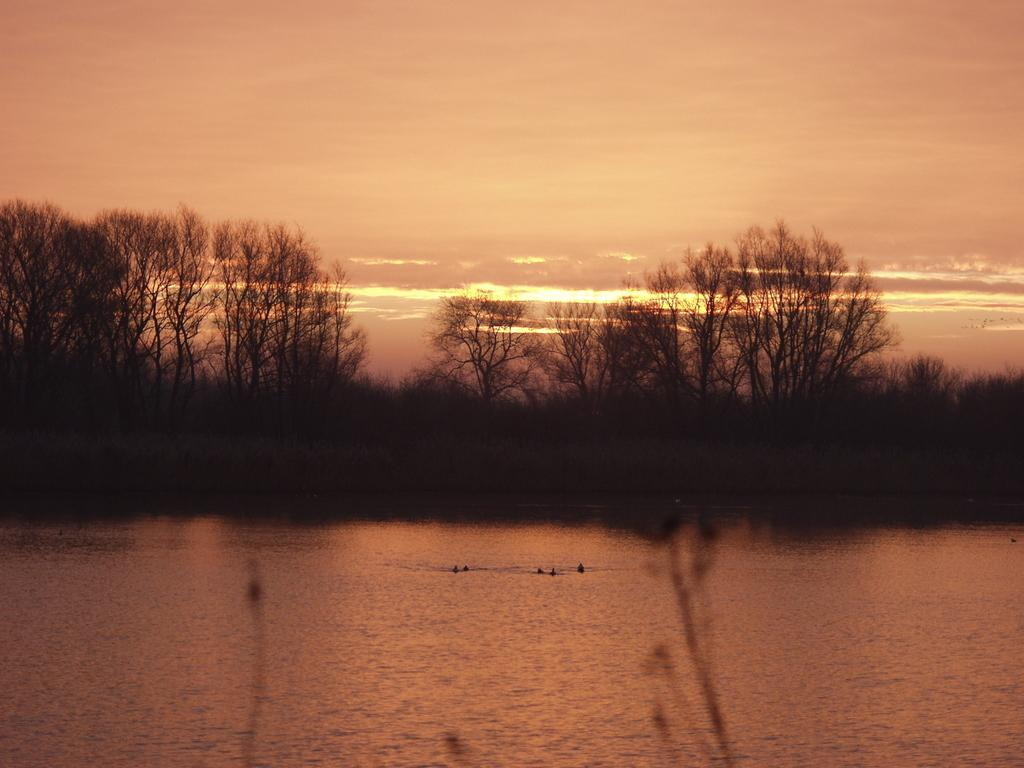What is at the bottom of the image? There is water at the bottom of the image. What can be seen in the middle of the image? There are trees in the middle of the image. What is visible in the image besides the water and trees? The sky is visible in the image. What can be observed in the sky? Clouds are present in the image. What type of question is being asked by the police in the image? There is no police officer or question present in the image. What color is the leaf on the tree in the image? There is no leaf mentioned in the provided facts, and the image does not show a close-up of a tree. 